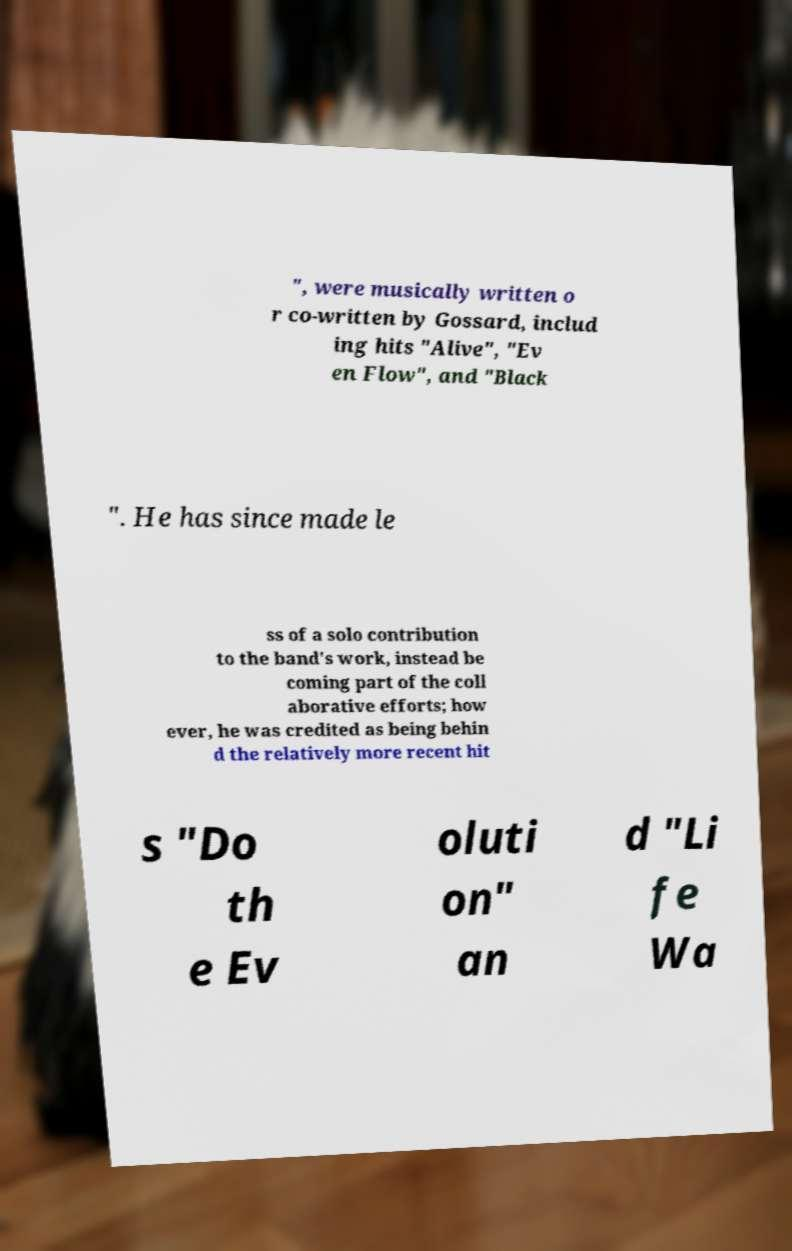Can you read and provide the text displayed in the image?This photo seems to have some interesting text. Can you extract and type it out for me? ", were musically written o r co-written by Gossard, includ ing hits "Alive", "Ev en Flow", and "Black ". He has since made le ss of a solo contribution to the band's work, instead be coming part of the coll aborative efforts; how ever, he was credited as being behin d the relatively more recent hit s "Do th e Ev oluti on" an d "Li fe Wa 